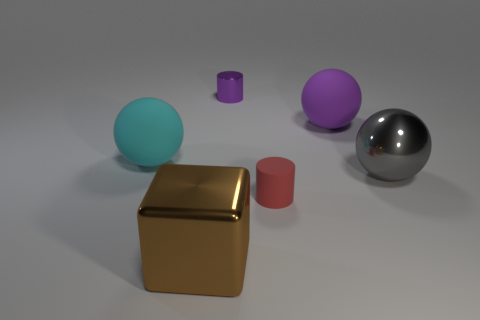What is the material of the brown thing?
Your response must be concise. Metal. Is there a cyan matte ball?
Offer a terse response. Yes. Are there the same number of brown objects that are to the left of the red matte thing and brown shiny blocks?
Make the answer very short. Yes. Is there anything else that has the same material as the tiny red thing?
Your answer should be compact. Yes. What number of large things are either metallic cylinders or brown cubes?
Your response must be concise. 1. What shape is the object that is the same color as the tiny metallic cylinder?
Offer a very short reply. Sphere. Do the purple object right of the red matte cylinder and the large cyan thing have the same material?
Keep it short and to the point. Yes. What is the material of the cylinder in front of the object to the right of the big purple sphere?
Offer a terse response. Rubber. What number of other rubber things have the same shape as the large purple matte object?
Your answer should be compact. 1. There is a cylinder that is left of the tiny thing to the right of the small cylinder that is behind the cyan matte thing; what is its size?
Provide a short and direct response. Small. 